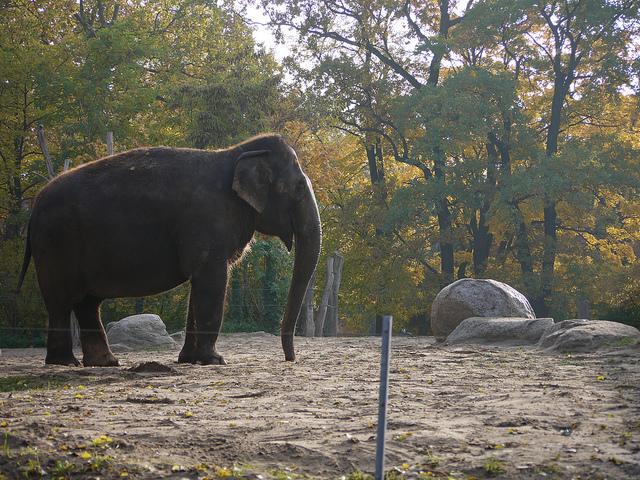What variety of elephant is pictured?
Give a very brief answer. African. Where was this photo taken?
Answer briefly. Zoo. Is this an Indian or an African elephant?
Give a very brief answer. Indian. What is the animal in front doing?
Give a very brief answer. Standing. What time of day would you say this picture was taken?
Give a very brief answer. Afternoon. Where is the elephant?
Answer briefly. Zoo. What is on the ground?
Short answer required. Elephant. What is an elephant doing in what looks like a private residence yard?
Quick response, please. Standing. How many types of animals are represented?
Answer briefly. 1. 